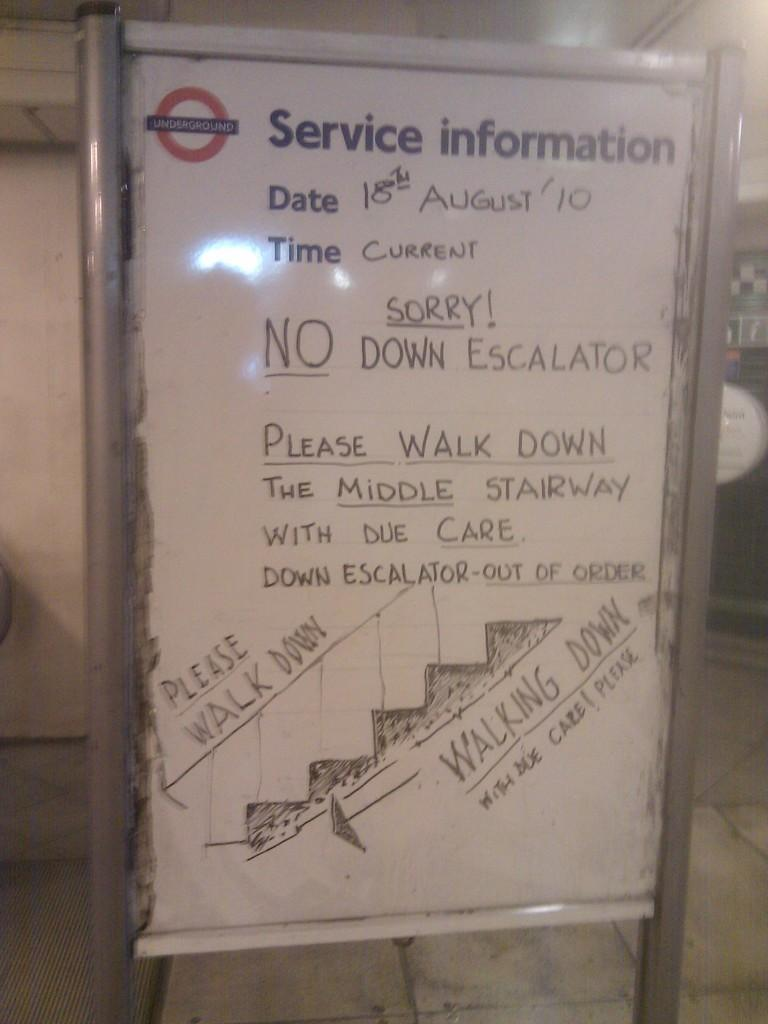<image>
Write a terse but informative summary of the picture. a Service Information sign is dated 18th August 10 